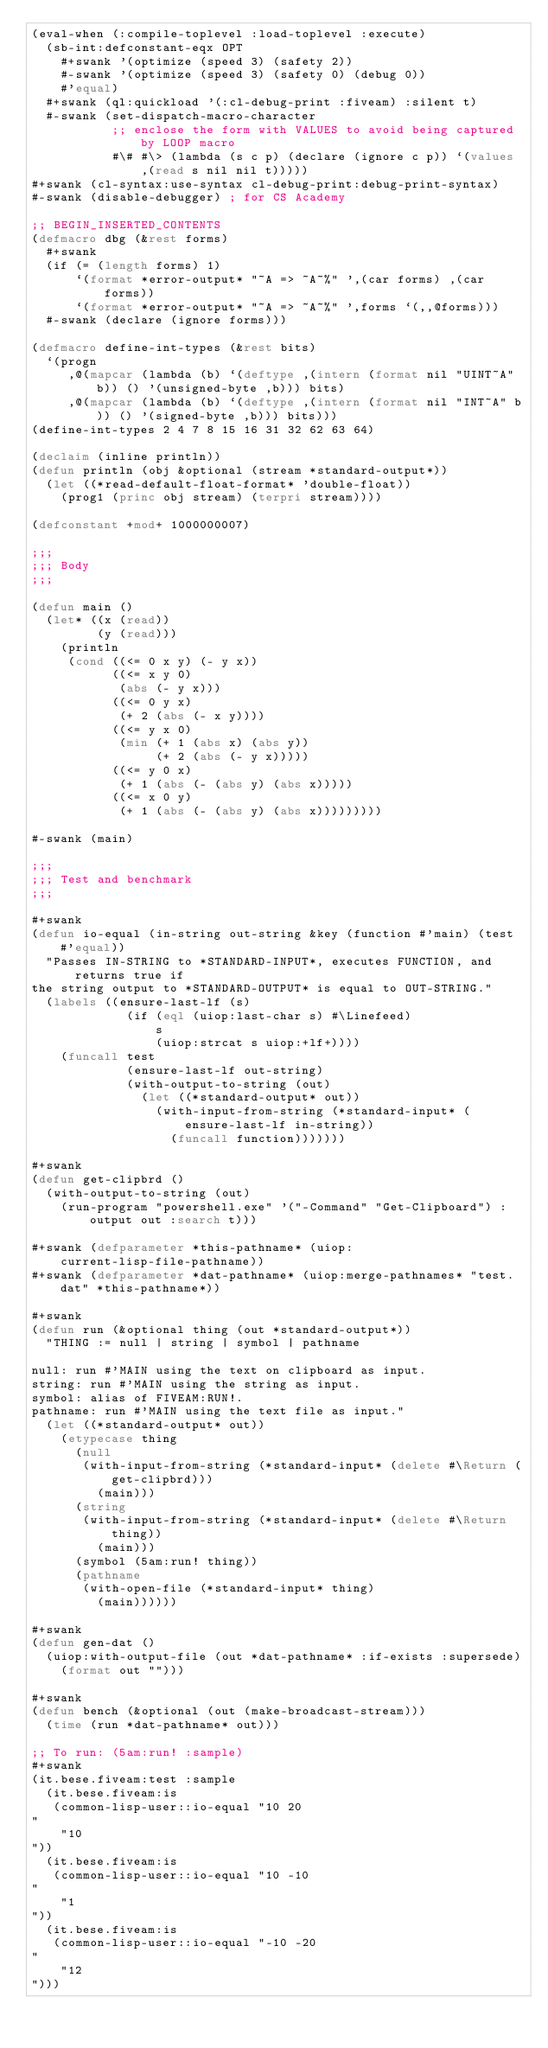Convert code to text. <code><loc_0><loc_0><loc_500><loc_500><_Lisp_>(eval-when (:compile-toplevel :load-toplevel :execute)
  (sb-int:defconstant-eqx OPT
    #+swank '(optimize (speed 3) (safety 2))
    #-swank '(optimize (speed 3) (safety 0) (debug 0))
    #'equal)
  #+swank (ql:quickload '(:cl-debug-print :fiveam) :silent t)
  #-swank (set-dispatch-macro-character
           ;; enclose the form with VALUES to avoid being captured by LOOP macro
           #\# #\> (lambda (s c p) (declare (ignore c p)) `(values ,(read s nil nil t)))))
#+swank (cl-syntax:use-syntax cl-debug-print:debug-print-syntax)
#-swank (disable-debugger) ; for CS Academy

;; BEGIN_INSERTED_CONTENTS
(defmacro dbg (&rest forms)
  #+swank
  (if (= (length forms) 1)
      `(format *error-output* "~A => ~A~%" ',(car forms) ,(car forms))
      `(format *error-output* "~A => ~A~%" ',forms `(,,@forms)))
  #-swank (declare (ignore forms)))

(defmacro define-int-types (&rest bits)
  `(progn
     ,@(mapcar (lambda (b) `(deftype ,(intern (format nil "UINT~A" b)) () '(unsigned-byte ,b))) bits)
     ,@(mapcar (lambda (b) `(deftype ,(intern (format nil "INT~A" b)) () '(signed-byte ,b))) bits)))
(define-int-types 2 4 7 8 15 16 31 32 62 63 64)

(declaim (inline println))
(defun println (obj &optional (stream *standard-output*))
  (let ((*read-default-float-format* 'double-float))
    (prog1 (princ obj stream) (terpri stream))))

(defconstant +mod+ 1000000007)

;;;
;;; Body
;;;

(defun main ()
  (let* ((x (read))
         (y (read)))
    (println
     (cond ((<= 0 x y) (- y x))
           ((<= x y 0)
            (abs (- y x)))
           ((<= 0 y x)
            (+ 2 (abs (- x y))))
           ((<= y x 0)
            (min (+ 1 (abs x) (abs y))
                 (+ 2 (abs (- y x)))))
           ((<= y 0 x)
            (+ 1 (abs (- (abs y) (abs x)))))
           ((<= x 0 y)
            (+ 1 (abs (- (abs y) (abs x)))))))))

#-swank (main)

;;;
;;; Test and benchmark
;;;

#+swank
(defun io-equal (in-string out-string &key (function #'main) (test #'equal))
  "Passes IN-STRING to *STANDARD-INPUT*, executes FUNCTION, and returns true if
the string output to *STANDARD-OUTPUT* is equal to OUT-STRING."
  (labels ((ensure-last-lf (s)
             (if (eql (uiop:last-char s) #\Linefeed)
                 s
                 (uiop:strcat s uiop:+lf+))))
    (funcall test
             (ensure-last-lf out-string)
             (with-output-to-string (out)
               (let ((*standard-output* out))
                 (with-input-from-string (*standard-input* (ensure-last-lf in-string))
                   (funcall function)))))))

#+swank
(defun get-clipbrd ()
  (with-output-to-string (out)
    (run-program "powershell.exe" '("-Command" "Get-Clipboard") :output out :search t)))

#+swank (defparameter *this-pathname* (uiop:current-lisp-file-pathname))
#+swank (defparameter *dat-pathname* (uiop:merge-pathnames* "test.dat" *this-pathname*))

#+swank
(defun run (&optional thing (out *standard-output*))
  "THING := null | string | symbol | pathname

null: run #'MAIN using the text on clipboard as input.
string: run #'MAIN using the string as input.
symbol: alias of FIVEAM:RUN!.
pathname: run #'MAIN using the text file as input."
  (let ((*standard-output* out))
    (etypecase thing
      (null
       (with-input-from-string (*standard-input* (delete #\Return (get-clipbrd)))
         (main)))
      (string
       (with-input-from-string (*standard-input* (delete #\Return thing))
         (main)))
      (symbol (5am:run! thing))
      (pathname
       (with-open-file (*standard-input* thing)
         (main))))))

#+swank
(defun gen-dat ()
  (uiop:with-output-file (out *dat-pathname* :if-exists :supersede)
    (format out "")))

#+swank
(defun bench (&optional (out (make-broadcast-stream)))
  (time (run *dat-pathname* out)))

;; To run: (5am:run! :sample)
#+swank
(it.bese.fiveam:test :sample
  (it.bese.fiveam:is
   (common-lisp-user::io-equal "10 20
"
    "10
"))
  (it.bese.fiveam:is
   (common-lisp-user::io-equal "10 -10
"
    "1
"))
  (it.bese.fiveam:is
   (common-lisp-user::io-equal "-10 -20
"
    "12
")))
</code> 